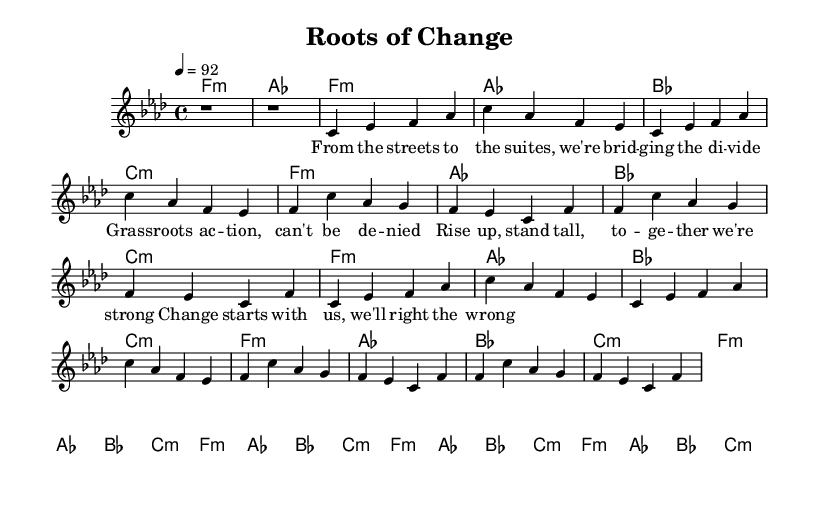What is the key signature of this music? The key signature is F minor, which contains four flats (B♭, E♭, A♭, and D♭). This is determined from the initial part of the sheet music where the key signature is indicated.
Answer: F minor What is the time signature of the piece? The time signature is 4/4, which is indicated at the beginning of the score. This means there are four beats in each measure and the quarter note receives one beat.
Answer: 4/4 What is the tempo marking for this piece? The tempo marking is 4 = 92, meaning the piece should be played at 92 beats per minute. This is noted in the header section of the score.
Answer: 92 How many verses are in the song? There are two verses in the song. This can be confirmed by reading the structure of the sheet music where the verses are labeled accordingly and repeated.
Answer: 2 What is the main theme of the lyrics in the first verse? The main theme of the lyrics in the first verse focuses on bridging divides through grassroots action and empowerment. The keywords convey a strong message of unity and social action.
Answer: Bridging divides What is the primary chord used in the Chorus sections? The primary chord used in the chorus sections is F minor. This is evident from the chord progression shown in the harmonies, highlighting F minor as a recurring element.
Answer: F minor How many times does the chorus repeat in the music? The chorus repeats four times throughout the piece, as indicated in the structure where each chorus section is marked after the verses.
Answer: 4 